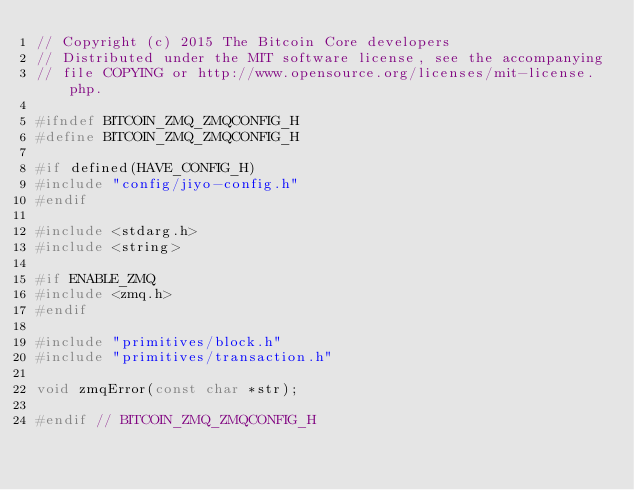Convert code to text. <code><loc_0><loc_0><loc_500><loc_500><_C_>// Copyright (c) 2015 The Bitcoin Core developers
// Distributed under the MIT software license, see the accompanying
// file COPYING or http://www.opensource.org/licenses/mit-license.php.

#ifndef BITCOIN_ZMQ_ZMQCONFIG_H
#define BITCOIN_ZMQ_ZMQCONFIG_H

#if defined(HAVE_CONFIG_H)
#include "config/jiyo-config.h"
#endif

#include <stdarg.h>
#include <string>

#if ENABLE_ZMQ
#include <zmq.h>
#endif

#include "primitives/block.h"
#include "primitives/transaction.h"

void zmqError(const char *str);

#endif // BITCOIN_ZMQ_ZMQCONFIG_H
</code> 